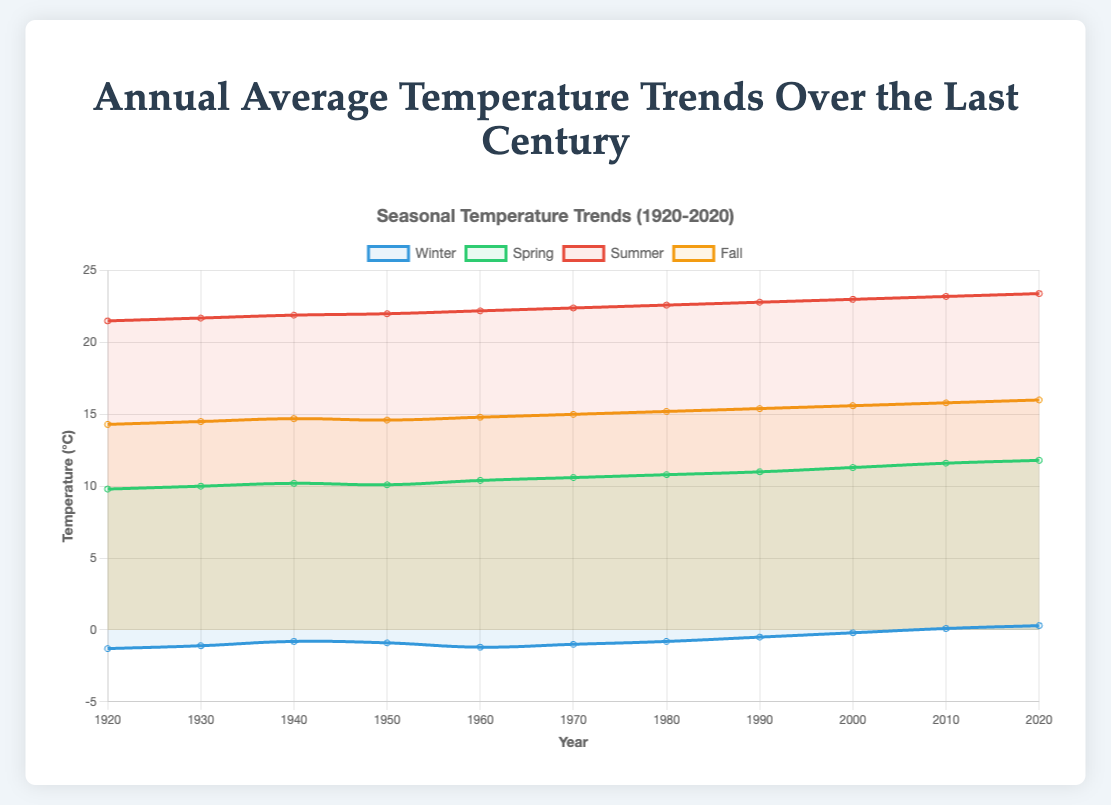Which season shows the highest temperature in 2020? To find which season had the highest temperature in 2020, compare the final data points for each season. Winter: 0.3, Spring: 11.8, Summer: 23.4, Fall: 16.0. Summer has the highest value.
Answer: Summer How did the average temperature for Spring change from 1920 to 2020? Calculate the difference: Spring temperature in 2020 is 11.8, in 1920 is 9.8. Subtract 9.8 from 11.8 to find the change: 11.8 - 9.8 = 2.0
Answer: 2.0 Which season had the most significant increase in temperature between 1920 and 2020? Calculate the difference for each season from 1920 to 2020. Winter: 0.3 - (-1.3) = 1.6; Spring: 11.8 - 9.8 = 2.0; Summer: 23.4 - 21.5 = 1.9; Fall: 16.0 - 14.3 = 1.7. Spring has the highest increase.
Answer: Spring What was the trend for Winter temperatures over the century? Observe the line for Winter on the plot from 1920 to 2020. The temperatures show an increasing trend, moving from -1.3 in 1920 to 0.3 in 2020.
Answer: Increasing Between which two decades did Summer experience the largest temperature increase? Look at the differences between consecutive decades for Summer. The increases are: 1930-1920 (21.7-21.5 = 0.2), 1940-1930 (21.9-21.7 = 0.2), 1950-1940 (22.0-21.9 = 0.1), etc. The largest increase is between 1990-1980 (22.8-22.6 = 0.2). Sum up, the largest increase is observed between 1990 and 2000 (23.0-22.8 = 0.2).
Answer: 1990 and 2000 Which season had the least variation in temperature over the century? Compute the range (max-min) for each season over the entire century. Winter: 1.6, Spring: 2.0, Summer: 1.9, Fall: 1.7. The Winter season had the least variation.
Answer: Winter What was the average annual temperature for Fall in the 1960s? The Fall temperatures in the 1960s are approximately at 14.8 degrees.
Answer: 14.8 Identify which season shows the least temperature increase in the last decade (2010 to 2020). Find the difference between 2020 and 2010 for each season. Winter: 0.3 - 0.1 = 0.2, Spring: 11.8 - 11.6 = 0.2, Summer: 23.4 - 23.2 = 0.2, Fall: 16.0 - 15.8 = 0.2. All seasons show an equal increase of 0.2.
Answer: All equal How does the temperature trend for Fall compare to Winter from 1920 to 2020? Compare the initial and final temperatures for both seasons: Winter from -1.3 to 0.3 (increase of 1.6), Fall from 14.3 to 16.0 (increase of 1.7). Both show an increasing trend, but Fall has a slightly higher increase.
Answer: Both increasing, Fall slightly higher 